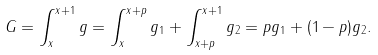Convert formula to latex. <formula><loc_0><loc_0><loc_500><loc_500>G = \int _ { x } ^ { x + 1 } g = \int _ { x } ^ { x + p } g _ { 1 } + \int _ { x + p } ^ { x + 1 } g _ { 2 } = p g _ { 1 } + ( 1 - p ) g _ { 2 } .</formula> 